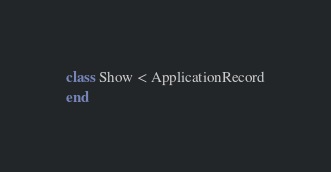Convert code to text. <code><loc_0><loc_0><loc_500><loc_500><_Ruby_>class Show < ApplicationRecord
end
</code> 